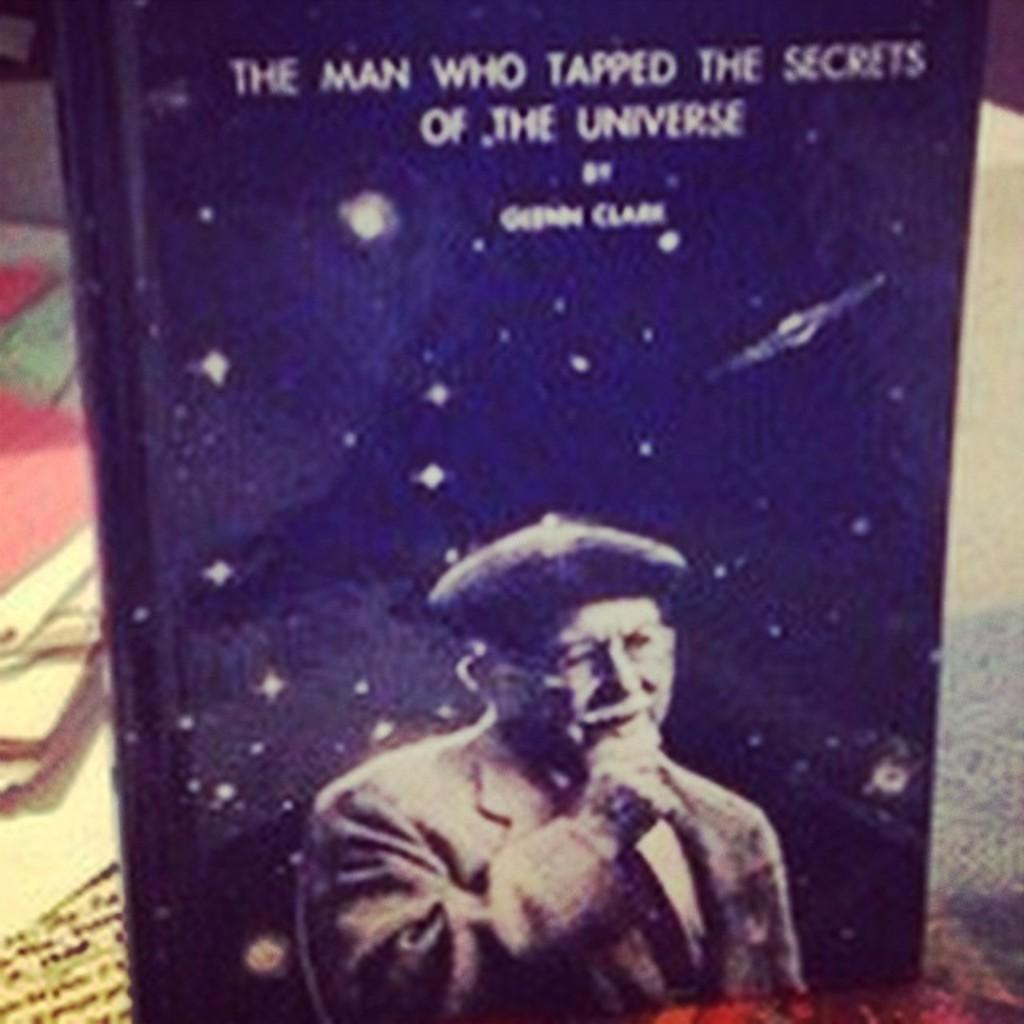<image>
Present a compact description of the photo's key features. a book titled the man who tapped the secrets of the universe written by george clark. 